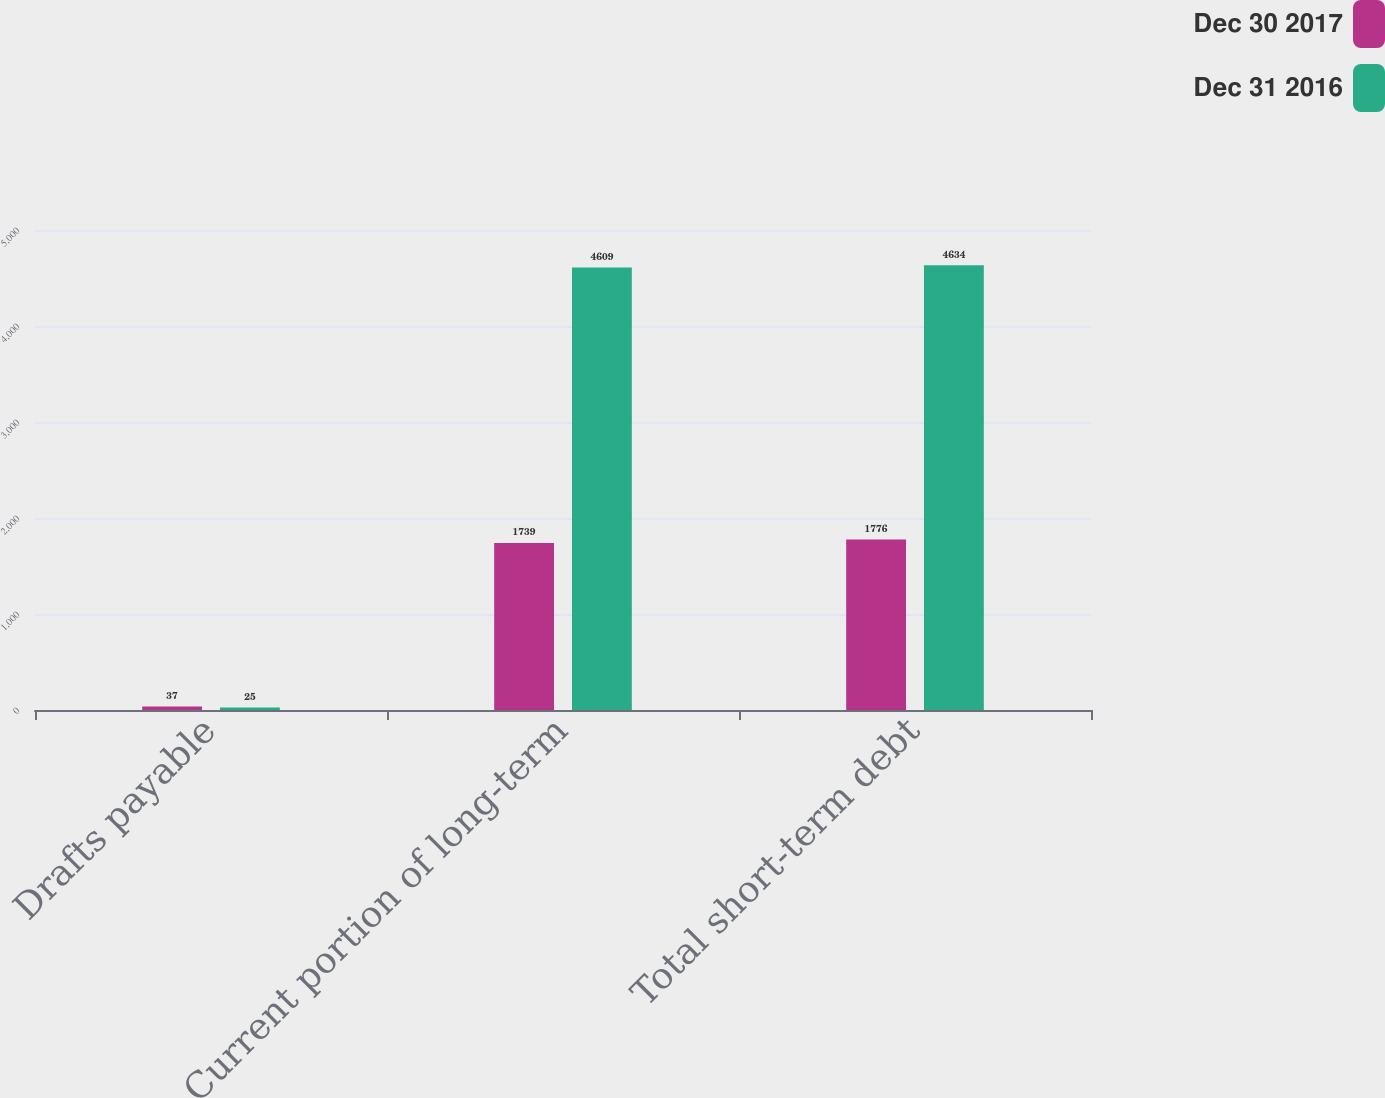<chart> <loc_0><loc_0><loc_500><loc_500><stacked_bar_chart><ecel><fcel>Drafts payable<fcel>Current portion of long-term<fcel>Total short-term debt<nl><fcel>Dec 30 2017<fcel>37<fcel>1739<fcel>1776<nl><fcel>Dec 31 2016<fcel>25<fcel>4609<fcel>4634<nl></chart> 